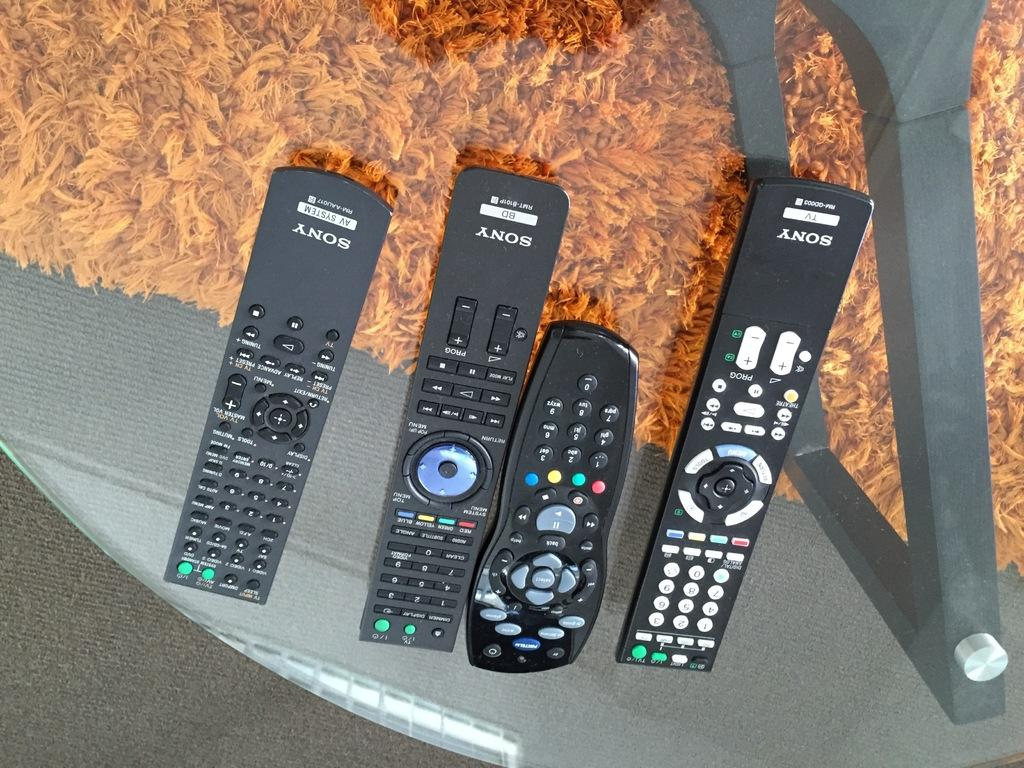<image>
Summarize the visual content of the image. A collection of Sony remote controls are displayed over an orange rug. 